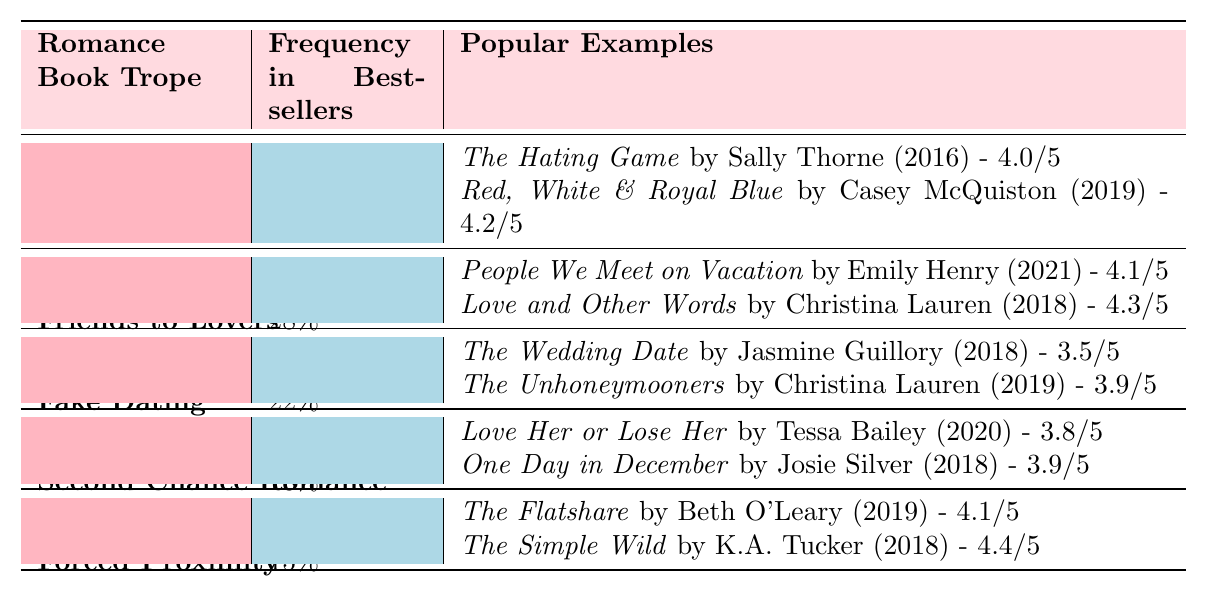What is the most common romance book trope in bestsellers? The most common trope is "Enemies to Lovers," which appears at a frequency of 32% in bestsellers.
Answer: Enemies to Lovers How many popular examples are listed for the "Fake Dating" trope? There are two popular examples listed for the "Fake Dating" trope: "The Wedding Date" and "The Unhoneymooners."
Answer: 2 What is the Goodreads rating of "The Simple Wild"? "The Simple Wild," written by K.A. Tucker, has a Goodreads rating of 4.4.
Answer: 4.4 Which trope has the lowest frequency in bestsellers? The "Forced Proximity" trope has the lowest frequency at 15% in bestsellers.
Answer: Forced Proximity What is the average Goodreads rating of the popular examples for the "Friends to Lovers" trope? The ratings are 4.1 for "People We Meet on Vacation" and 4.3 for "Love and Other Words;" the average is (4.1 + 4.3) / 2 = 4.2.
Answer: 4.2 Did "The Hating Game" receive a higher Goodreads rating than "The Wedding Date"? "The Hating Game" has a rating of 4.0 while "The Wedding Date" has 3.5, so yes, it received a higher rating.
Answer: Yes How many tropes in total are mentioned in the table? There are five different tropes mentioned in the table: Enemies to Lovers, Friends to Lovers, Fake Dating, Second Chance Romance, and Forced Proximity.
Answer: 5 Which trope has a frequency that is at least 20% but less than 30%? "Friends to Lovers" with a frequency of 28% fits this criterion.
Answer: Friends to Lovers What percentage of bestsellers feature the "Second Chance Romance" trope? The "Second Chance Romance" trope is featured in 18% of bestsellers.
Answer: 18% Is "Red, White & Royal Blue" an example of the "Fake Dating" trope? No, "Red, White & Royal Blue" is listed as an example of the "Enemies to Lovers" trope, not "Fake Dating."
Answer: No 